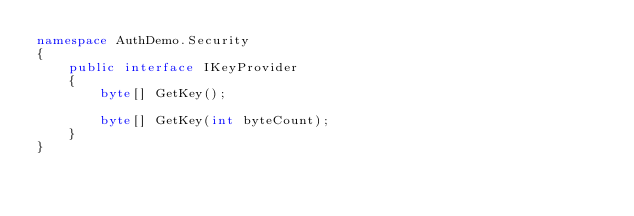Convert code to text. <code><loc_0><loc_0><loc_500><loc_500><_C#_>namespace AuthDemo.Security
{
    public interface IKeyProvider
    {
        byte[] GetKey();

        byte[] GetKey(int byteCount);
    }
}</code> 